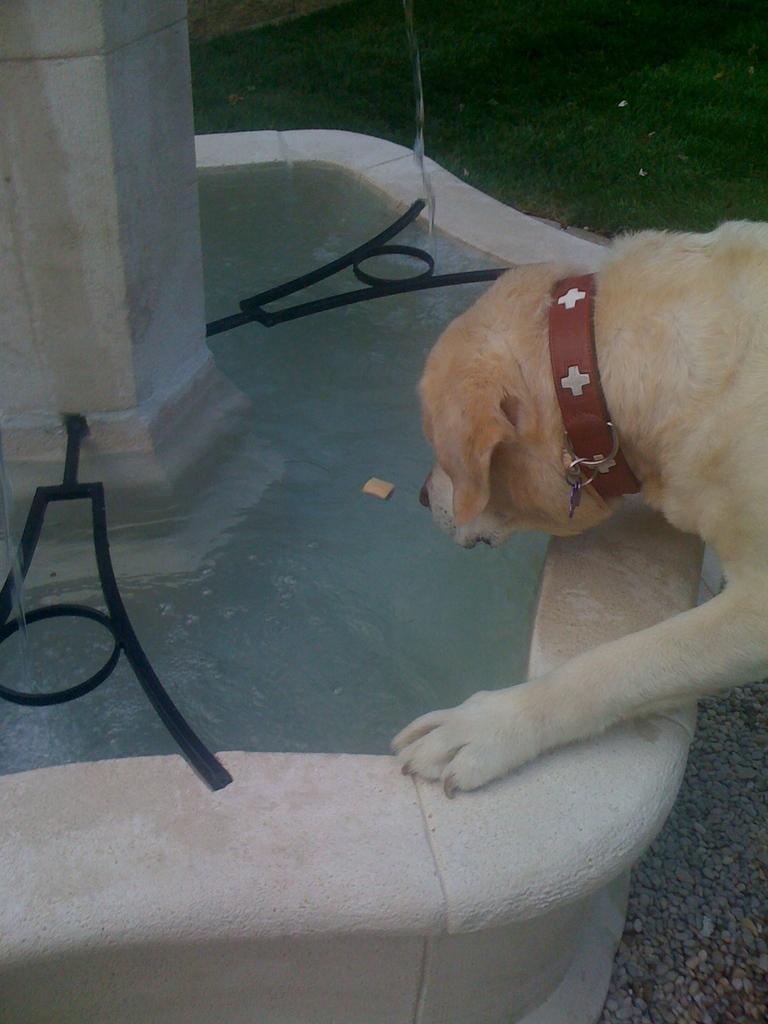Could you give a brief overview of what you see in this image? In the image there is a small wall in the round shape. In that there is water. And also there is a pillar and black objects in that. On the right side of the image there is a dog. At the top of the image there is grass on the ground. 